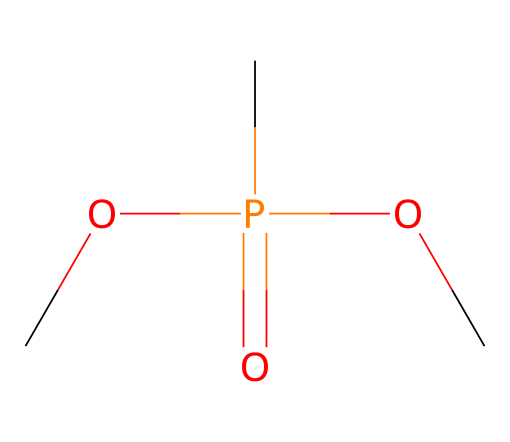What is the main functional group present in dimethyl methylphosphonate? The structure shows a phosphorus atom bonded to oxygen, indicating that the main functional group is a phosphonate.
Answer: phosphonate How many carbon atoms are in dimethyl methylphosphonate? The SMILES representation has two "C" symbols, which indicate there are two carbon atoms present.
Answer: two What type of bond connects the phosphorus atom to the oxygen atoms in dimethyl methylphosphonate? The structure shows phosphorus bonded to oxygen with single bonds (primary bonds), confirming that the connection is via single bonds.
Answer: single bonds How many total oxygen atoms are present in dimethyl methylphosphonate? The SMILES representation contains three "O" symbols, indicating there are three oxygen atoms in the compound.
Answer: three What is the total valence charge of dimethyl methylphosphonate? The phosphorus typically has a valence of 5, the oxygen has 2, and carbon has 4, but the total charge is neutral, as the structure does not indicate any charge.
Answer: neutral 